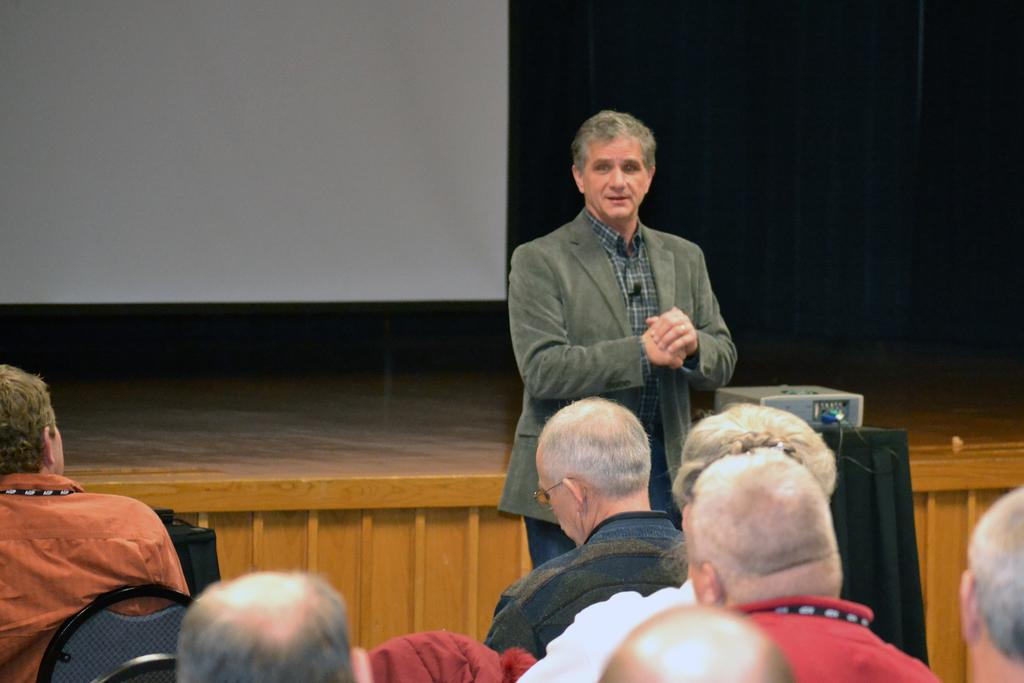What is the man in the image doing? The man is standing in the image. What is the man wearing? The man is wearing a coat. What are the people in the image doing? The people are sitting on chairs in the image. What device is visible in the image? There is a projector visible in the image. What feature can be seen in the background of the image? There is a stage in the image. What date is circled on the calendar in the image? There is no calendar present in the image. How does the rainstorm affect the people sitting on chairs in the image? There is no rainstorm present in the image; the people are sitting indoors. 